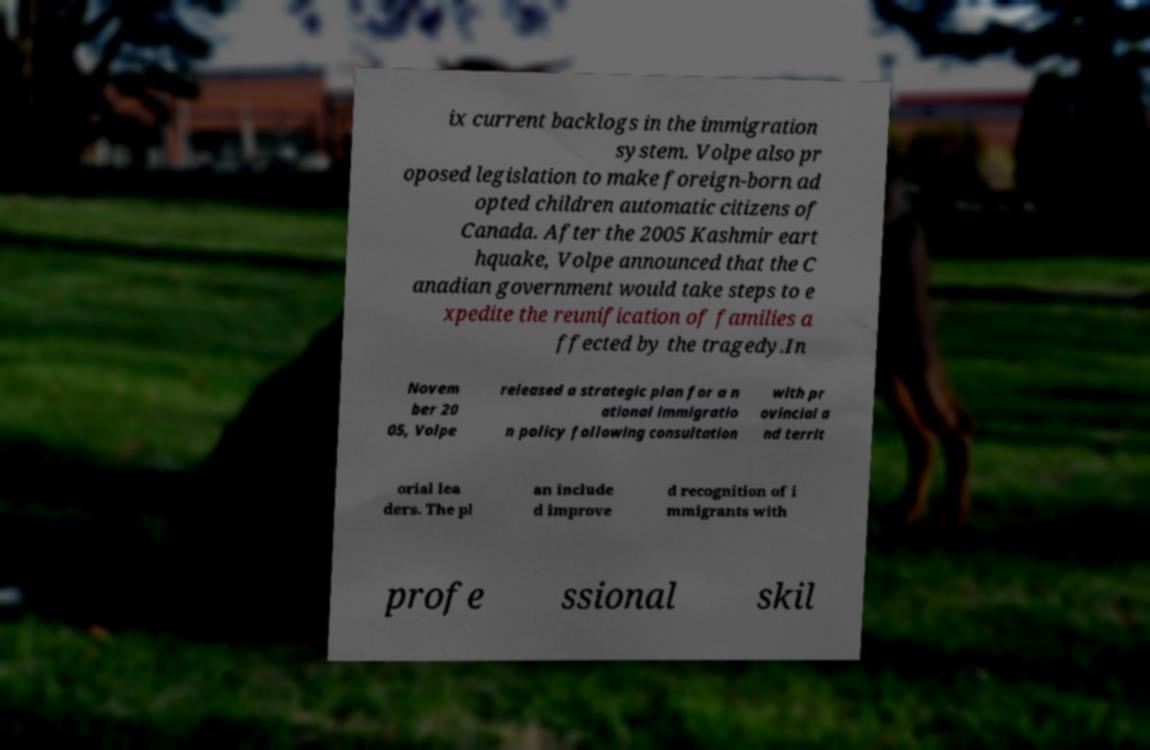Could you extract and type out the text from this image? ix current backlogs in the immigration system. Volpe also pr oposed legislation to make foreign-born ad opted children automatic citizens of Canada. After the 2005 Kashmir eart hquake, Volpe announced that the C anadian government would take steps to e xpedite the reunification of families a ffected by the tragedy.In Novem ber 20 05, Volpe released a strategic plan for a n ational immigratio n policy following consultation with pr ovincial a nd territ orial lea ders. The pl an include d improve d recognition of i mmigrants with profe ssional skil 